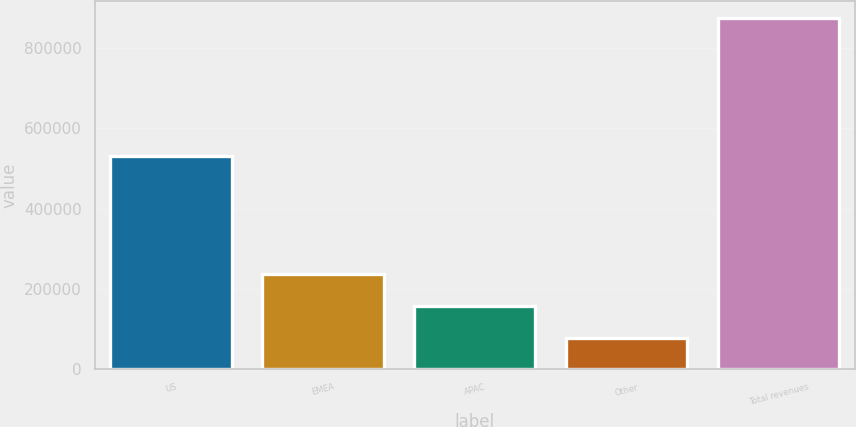<chart> <loc_0><loc_0><loc_500><loc_500><bar_chart><fcel>US<fcel>EMEA<fcel>APAC<fcel>Other<fcel>Total revenues<nl><fcel>530111<fcel>236918<fcel>157333<fcel>77749<fcel>873592<nl></chart> 